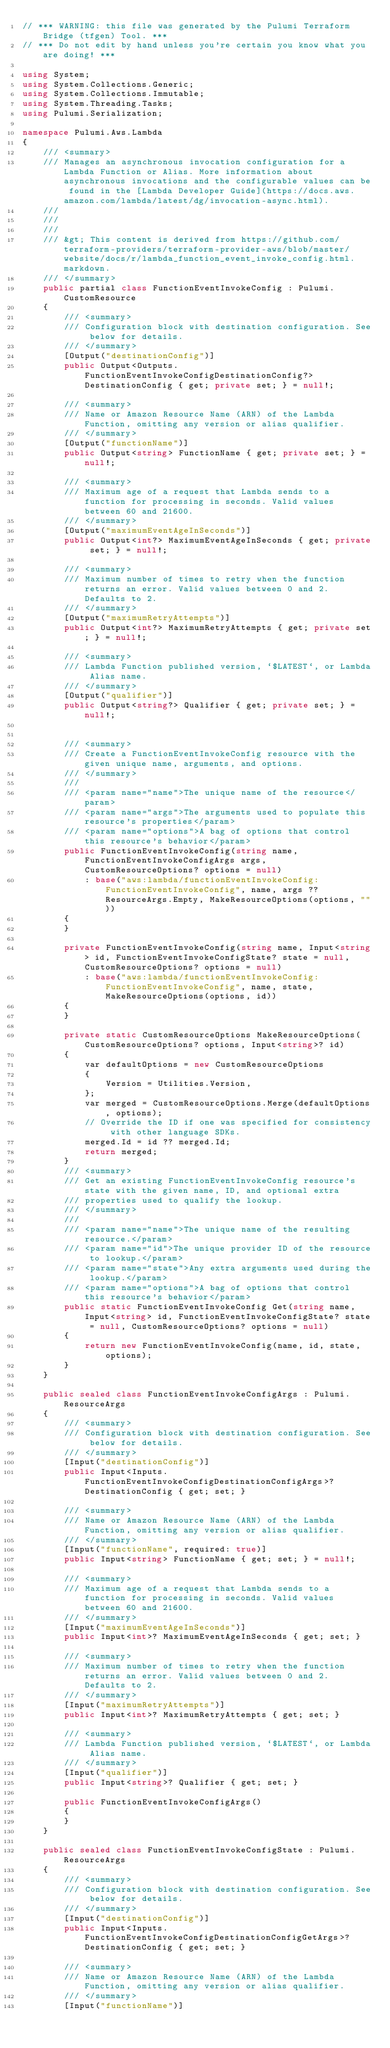<code> <loc_0><loc_0><loc_500><loc_500><_C#_>// *** WARNING: this file was generated by the Pulumi Terraform Bridge (tfgen) Tool. ***
// *** Do not edit by hand unless you're certain you know what you are doing! ***

using System;
using System.Collections.Generic;
using System.Collections.Immutable;
using System.Threading.Tasks;
using Pulumi.Serialization;

namespace Pulumi.Aws.Lambda
{
    /// <summary>
    /// Manages an asynchronous invocation configuration for a Lambda Function or Alias. More information about asynchronous invocations and the configurable values can be found in the [Lambda Developer Guide](https://docs.aws.amazon.com/lambda/latest/dg/invocation-async.html).
    /// 
    /// 
    /// 
    /// &gt; This content is derived from https://github.com/terraform-providers/terraform-provider-aws/blob/master/website/docs/r/lambda_function_event_invoke_config.html.markdown.
    /// </summary>
    public partial class FunctionEventInvokeConfig : Pulumi.CustomResource
    {
        /// <summary>
        /// Configuration block with destination configuration. See below for details.
        /// </summary>
        [Output("destinationConfig")]
        public Output<Outputs.FunctionEventInvokeConfigDestinationConfig?> DestinationConfig { get; private set; } = null!;

        /// <summary>
        /// Name or Amazon Resource Name (ARN) of the Lambda Function, omitting any version or alias qualifier.
        /// </summary>
        [Output("functionName")]
        public Output<string> FunctionName { get; private set; } = null!;

        /// <summary>
        /// Maximum age of a request that Lambda sends to a function for processing in seconds. Valid values between 60 and 21600.
        /// </summary>
        [Output("maximumEventAgeInSeconds")]
        public Output<int?> MaximumEventAgeInSeconds { get; private set; } = null!;

        /// <summary>
        /// Maximum number of times to retry when the function returns an error. Valid values between 0 and 2. Defaults to 2.
        /// </summary>
        [Output("maximumRetryAttempts")]
        public Output<int?> MaximumRetryAttempts { get; private set; } = null!;

        /// <summary>
        /// Lambda Function published version, `$LATEST`, or Lambda Alias name.
        /// </summary>
        [Output("qualifier")]
        public Output<string?> Qualifier { get; private set; } = null!;


        /// <summary>
        /// Create a FunctionEventInvokeConfig resource with the given unique name, arguments, and options.
        /// </summary>
        ///
        /// <param name="name">The unique name of the resource</param>
        /// <param name="args">The arguments used to populate this resource's properties</param>
        /// <param name="options">A bag of options that control this resource's behavior</param>
        public FunctionEventInvokeConfig(string name, FunctionEventInvokeConfigArgs args, CustomResourceOptions? options = null)
            : base("aws:lambda/functionEventInvokeConfig:FunctionEventInvokeConfig", name, args ?? ResourceArgs.Empty, MakeResourceOptions(options, ""))
        {
        }

        private FunctionEventInvokeConfig(string name, Input<string> id, FunctionEventInvokeConfigState? state = null, CustomResourceOptions? options = null)
            : base("aws:lambda/functionEventInvokeConfig:FunctionEventInvokeConfig", name, state, MakeResourceOptions(options, id))
        {
        }

        private static CustomResourceOptions MakeResourceOptions(CustomResourceOptions? options, Input<string>? id)
        {
            var defaultOptions = new CustomResourceOptions
            {
                Version = Utilities.Version,
            };
            var merged = CustomResourceOptions.Merge(defaultOptions, options);
            // Override the ID if one was specified for consistency with other language SDKs.
            merged.Id = id ?? merged.Id;
            return merged;
        }
        /// <summary>
        /// Get an existing FunctionEventInvokeConfig resource's state with the given name, ID, and optional extra
        /// properties used to qualify the lookup.
        /// </summary>
        ///
        /// <param name="name">The unique name of the resulting resource.</param>
        /// <param name="id">The unique provider ID of the resource to lookup.</param>
        /// <param name="state">Any extra arguments used during the lookup.</param>
        /// <param name="options">A bag of options that control this resource's behavior</param>
        public static FunctionEventInvokeConfig Get(string name, Input<string> id, FunctionEventInvokeConfigState? state = null, CustomResourceOptions? options = null)
        {
            return new FunctionEventInvokeConfig(name, id, state, options);
        }
    }

    public sealed class FunctionEventInvokeConfigArgs : Pulumi.ResourceArgs
    {
        /// <summary>
        /// Configuration block with destination configuration. See below for details.
        /// </summary>
        [Input("destinationConfig")]
        public Input<Inputs.FunctionEventInvokeConfigDestinationConfigArgs>? DestinationConfig { get; set; }

        /// <summary>
        /// Name or Amazon Resource Name (ARN) of the Lambda Function, omitting any version or alias qualifier.
        /// </summary>
        [Input("functionName", required: true)]
        public Input<string> FunctionName { get; set; } = null!;

        /// <summary>
        /// Maximum age of a request that Lambda sends to a function for processing in seconds. Valid values between 60 and 21600.
        /// </summary>
        [Input("maximumEventAgeInSeconds")]
        public Input<int>? MaximumEventAgeInSeconds { get; set; }

        /// <summary>
        /// Maximum number of times to retry when the function returns an error. Valid values between 0 and 2. Defaults to 2.
        /// </summary>
        [Input("maximumRetryAttempts")]
        public Input<int>? MaximumRetryAttempts { get; set; }

        /// <summary>
        /// Lambda Function published version, `$LATEST`, or Lambda Alias name.
        /// </summary>
        [Input("qualifier")]
        public Input<string>? Qualifier { get; set; }

        public FunctionEventInvokeConfigArgs()
        {
        }
    }

    public sealed class FunctionEventInvokeConfigState : Pulumi.ResourceArgs
    {
        /// <summary>
        /// Configuration block with destination configuration. See below for details.
        /// </summary>
        [Input("destinationConfig")]
        public Input<Inputs.FunctionEventInvokeConfigDestinationConfigGetArgs>? DestinationConfig { get; set; }

        /// <summary>
        /// Name or Amazon Resource Name (ARN) of the Lambda Function, omitting any version or alias qualifier.
        /// </summary>
        [Input("functionName")]</code> 